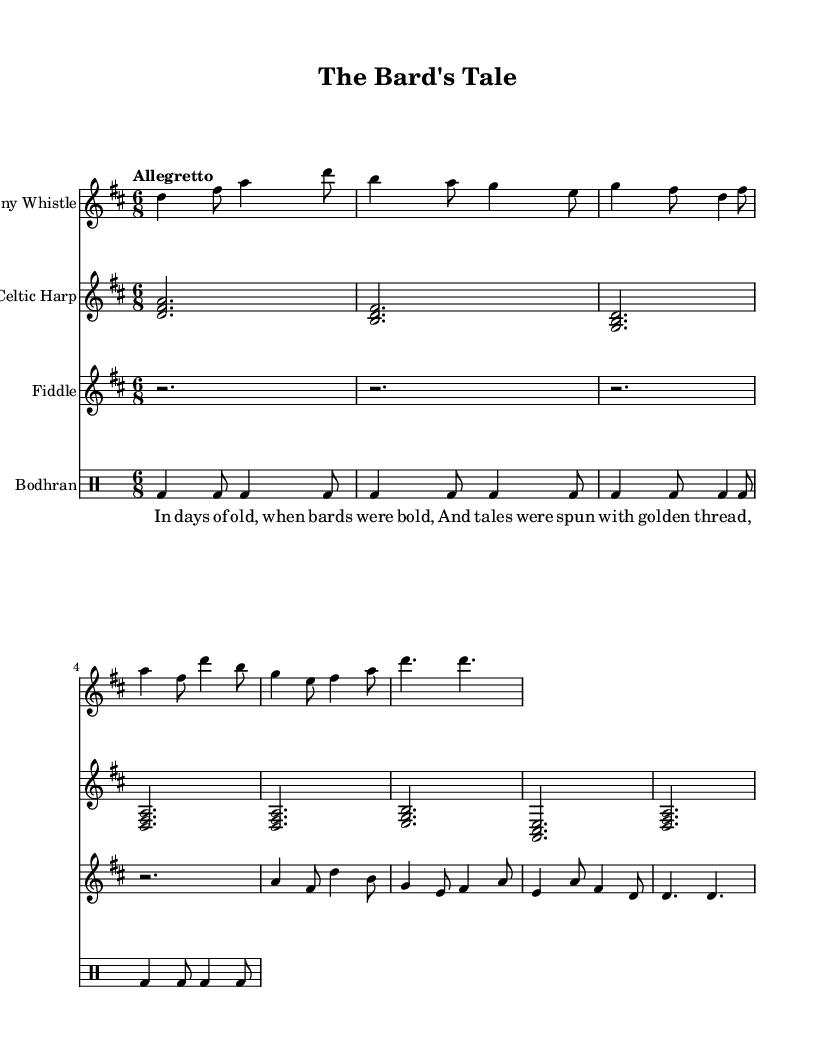What is the key signature of this music? The key signature is D major, indicated by two sharps (F# and C#) at the beginning of the staff.
Answer: D major What is the time signature of this music? The time signature is 6/8, which means there are six eighth-note beats in each measure, as shown at the beginning of the score.
Answer: 6/8 What is the tempo marking? The tempo marking is "Allegretto," which indicates a moderately fast speed. The term is found right above the global definition in the score.
Answer: Allegretto How many measures are in the penny whistle part? The penny whistle part consists of 8 measures, which can be counted from the notation shown for that instrument.
Answer: 8 What instruments are included in this score? The score includes Penny Whistle, Celtic Harp, Fiddle, and Bodhran, all listed at the beginning of each staff within the score.
Answer: Penny Whistle, Celtic Harp, Fiddle, Bodhran In the verse, what phrase is used to describe the times of the bards? The phrase "In days of old, when bards were bold" is used to describe the times of the bards, which is clearly indicated in the lyrics section.
Answer: In days of old, when bards were bold What is the rhythmic pattern of the bodhran section? The bodhran section consists of a steady beat pattern, consisting of alternating bass drum hits, notated in every eighth note of each measure.
Answer: bd4 bd8 